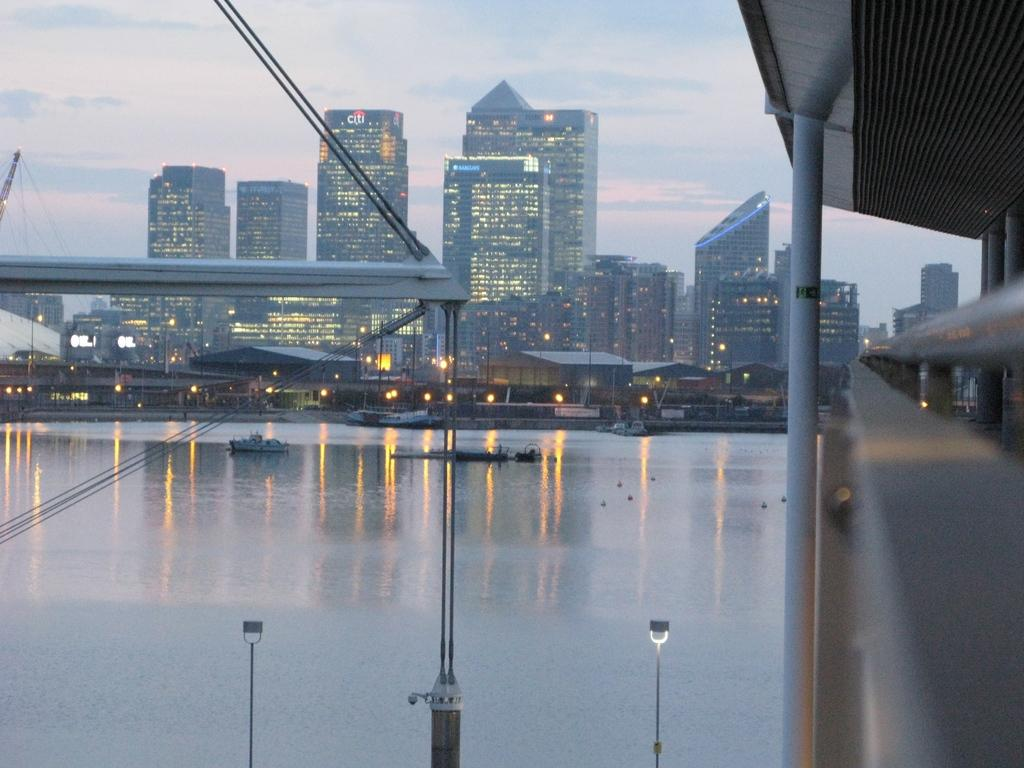What is present in the image that is used for transmitting signals or electricity? There are wires and poles in the image, which are used for transmitting signals or electricity. What can be seen floating on the water in the image? Ships are floating on the water in the image. What type of poles are present in the image? There are light poles in the image. What type of structures are visible in the image? Tower buildings are present in the image. What is visible in the background of the image? The sky is visible in the background of the image, and clouds are present in the sky. What type of jelly is being used to hold the ships together in the image? There is no jelly present in the image, and the ships are not being held together by any substance. Can you tell me how many credits are visible on the light poles in the image? There are no credits present on the light poles or anywhere else in the image. 